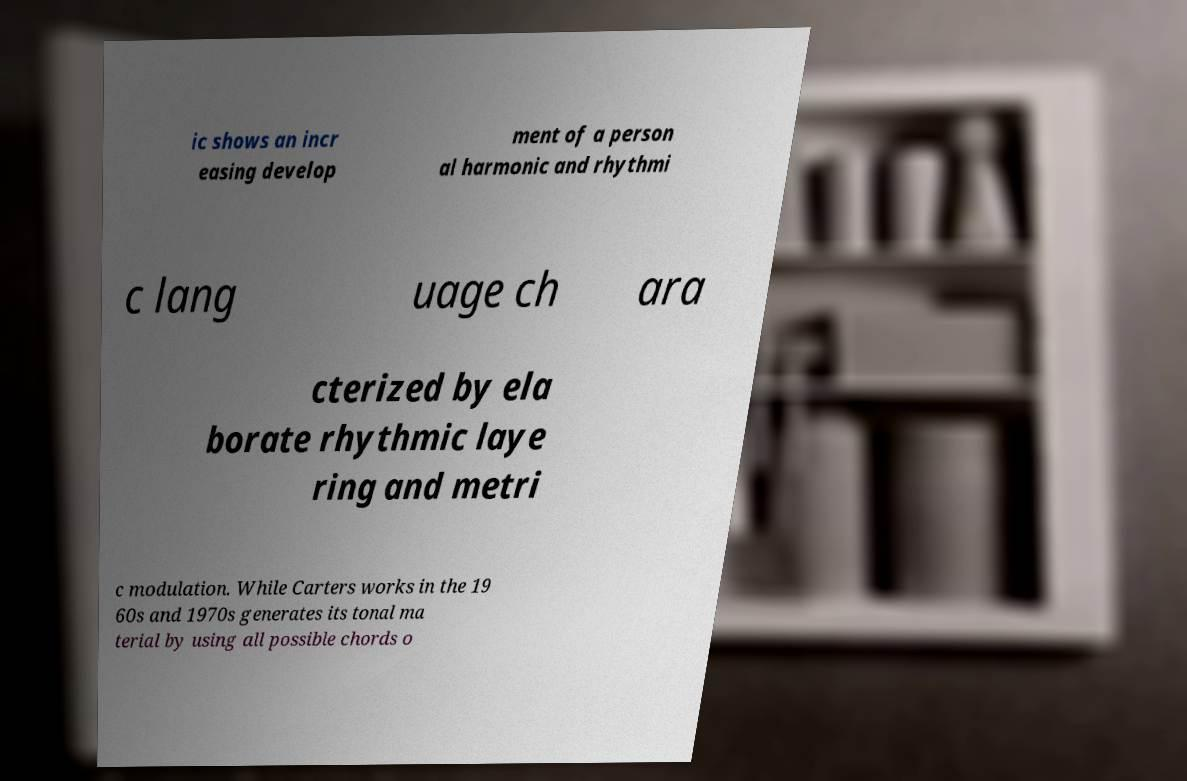What messages or text are displayed in this image? I need them in a readable, typed format. ic shows an incr easing develop ment of a person al harmonic and rhythmi c lang uage ch ara cterized by ela borate rhythmic laye ring and metri c modulation. While Carters works in the 19 60s and 1970s generates its tonal ma terial by using all possible chords o 